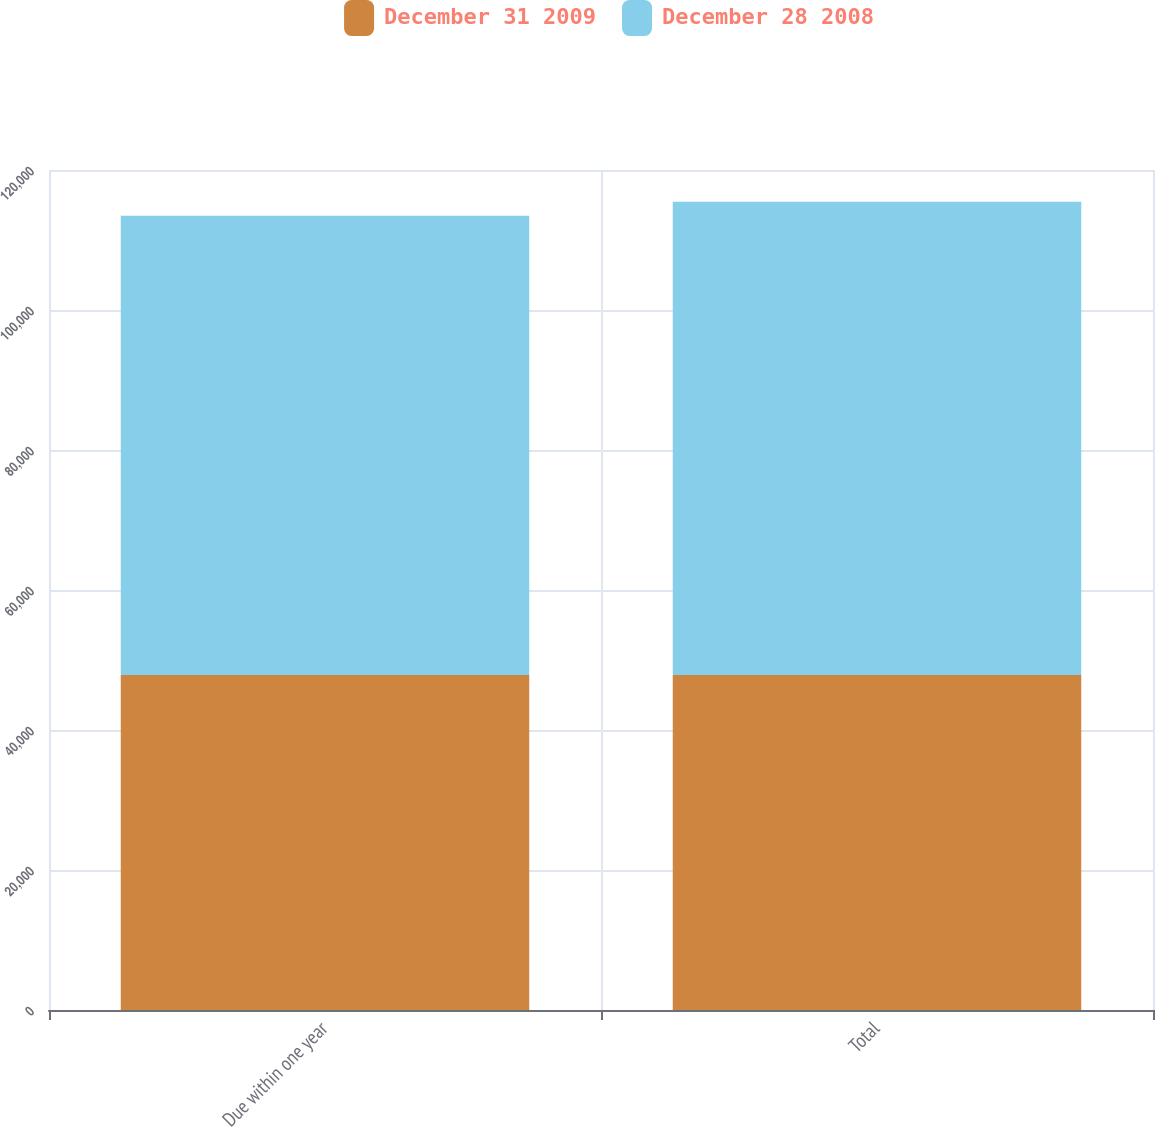Convert chart to OTSL. <chart><loc_0><loc_0><loc_500><loc_500><stacked_bar_chart><ecel><fcel>Due within one year<fcel>Total<nl><fcel>December 31 2009<fcel>47856<fcel>47856<nl><fcel>December 28 2008<fcel>65604<fcel>67619<nl></chart> 